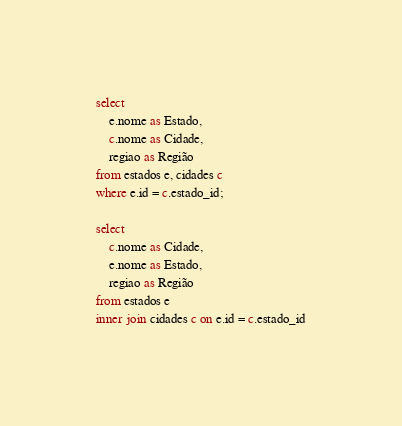<code> <loc_0><loc_0><loc_500><loc_500><_SQL_>select
    e.nome as Estado,
    c.nome as Cidade,
    regiao as Região
from estados e, cidades c
where e.id = c.estado_id;

select 
    c.nome as Cidade,
    e.nome as Estado,
    regiao as Região
from estados e
inner join cidades c on e.id = c.estado_id</code> 